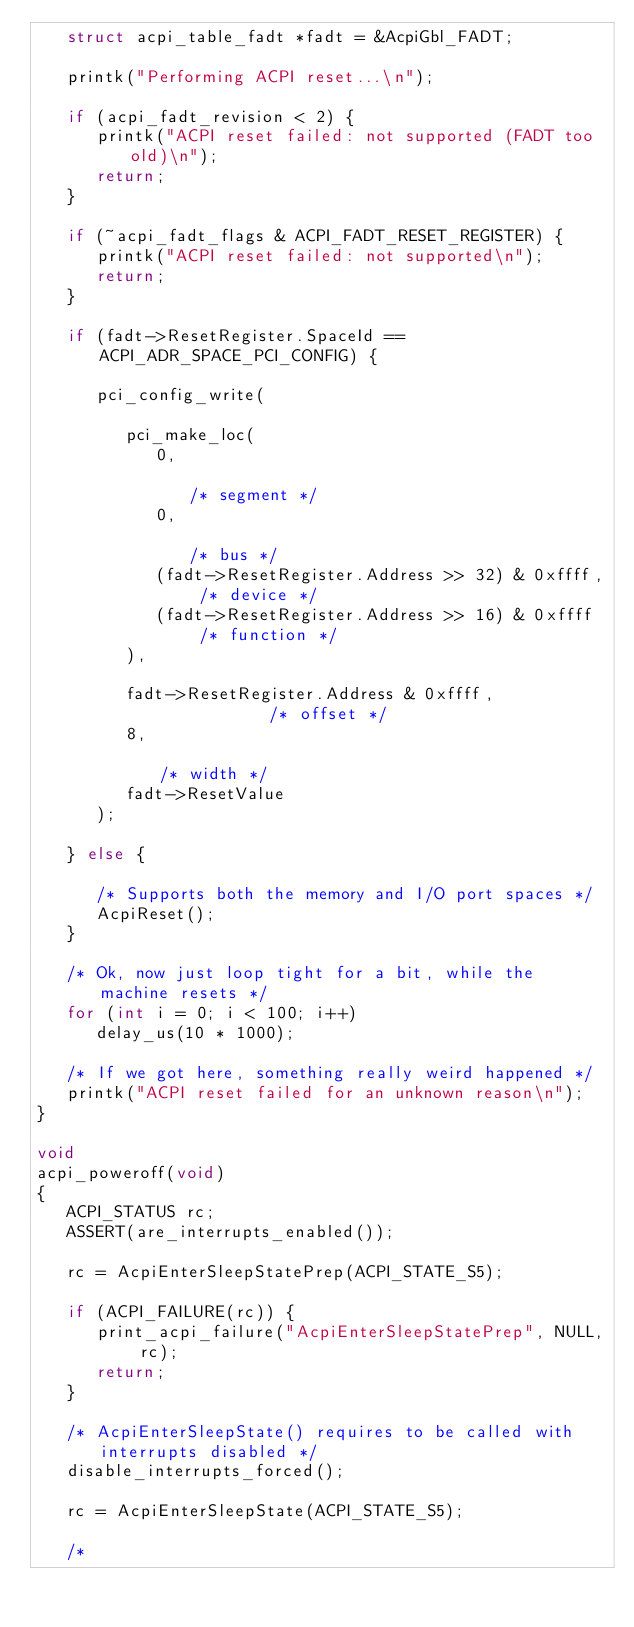<code> <loc_0><loc_0><loc_500><loc_500><_C_>   struct acpi_table_fadt *fadt = &AcpiGbl_FADT;

   printk("Performing ACPI reset...\n");

   if (acpi_fadt_revision < 2) {
      printk("ACPI reset failed: not supported (FADT too old)\n");
      return;
   }

   if (~acpi_fadt_flags & ACPI_FADT_RESET_REGISTER) {
      printk("ACPI reset failed: not supported\n");
      return;
   }

   if (fadt->ResetRegister.SpaceId == ACPI_ADR_SPACE_PCI_CONFIG) {

      pci_config_write(

         pci_make_loc(
            0,                                            /* segment */
            0,                                            /* bus */
            (fadt->ResetRegister.Address >> 32) & 0xffff, /* device */
            (fadt->ResetRegister.Address >> 16) & 0xffff  /* function */
         ),

         fadt->ResetRegister.Address & 0xffff,            /* offset */
         8,                                               /* width */
         fadt->ResetValue
      );

   } else {

      /* Supports both the memory and I/O port spaces */
      AcpiReset();
   }

   /* Ok, now just loop tight for a bit, while the machine resets */
   for (int i = 0; i < 100; i++)
      delay_us(10 * 1000);

   /* If we got here, something really weird happened */
   printk("ACPI reset failed for an unknown reason\n");
}

void
acpi_poweroff(void)
{
   ACPI_STATUS rc;
   ASSERT(are_interrupts_enabled());

   rc = AcpiEnterSleepStatePrep(ACPI_STATE_S5);

   if (ACPI_FAILURE(rc)) {
      print_acpi_failure("AcpiEnterSleepStatePrep", NULL, rc);
      return;
   }

   /* AcpiEnterSleepState() requires to be called with interrupts disabled */
   disable_interrupts_forced();

   rc = AcpiEnterSleepState(ACPI_STATE_S5);

   /*</code> 